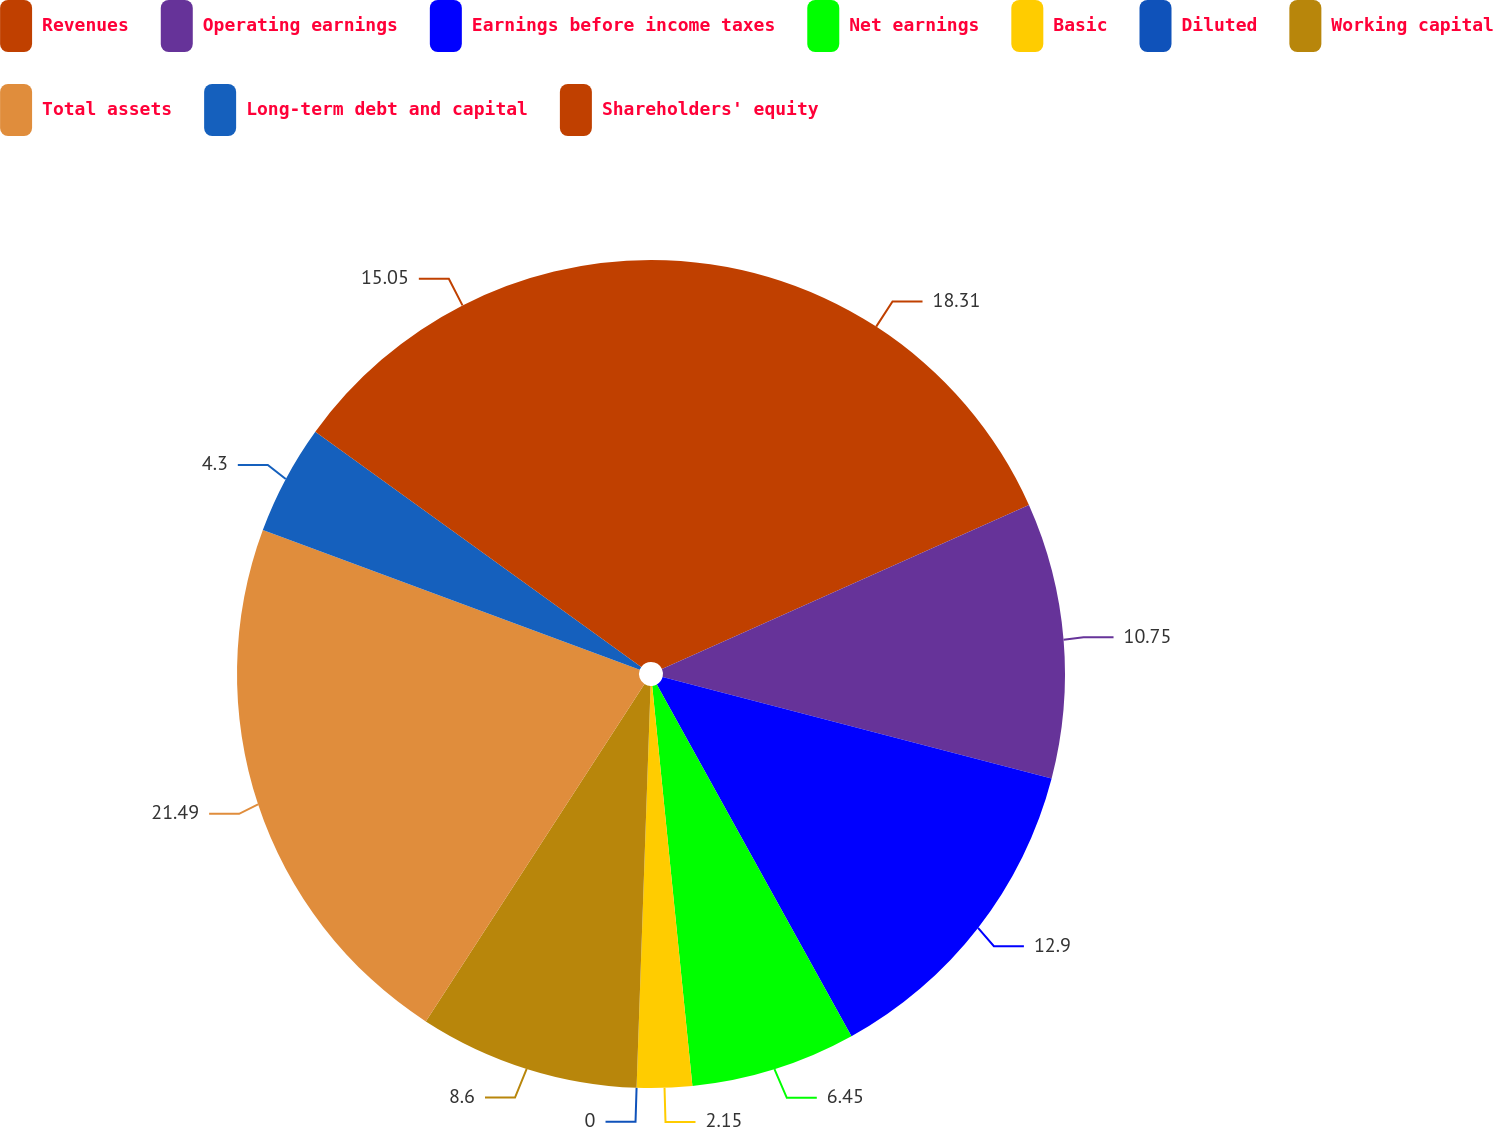Convert chart. <chart><loc_0><loc_0><loc_500><loc_500><pie_chart><fcel>Revenues<fcel>Operating earnings<fcel>Earnings before income taxes<fcel>Net earnings<fcel>Basic<fcel>Diluted<fcel>Working capital<fcel>Total assets<fcel>Long-term debt and capital<fcel>Shareholders' equity<nl><fcel>18.31%<fcel>10.75%<fcel>12.9%<fcel>6.45%<fcel>2.15%<fcel>0.0%<fcel>8.6%<fcel>21.5%<fcel>4.3%<fcel>15.05%<nl></chart> 